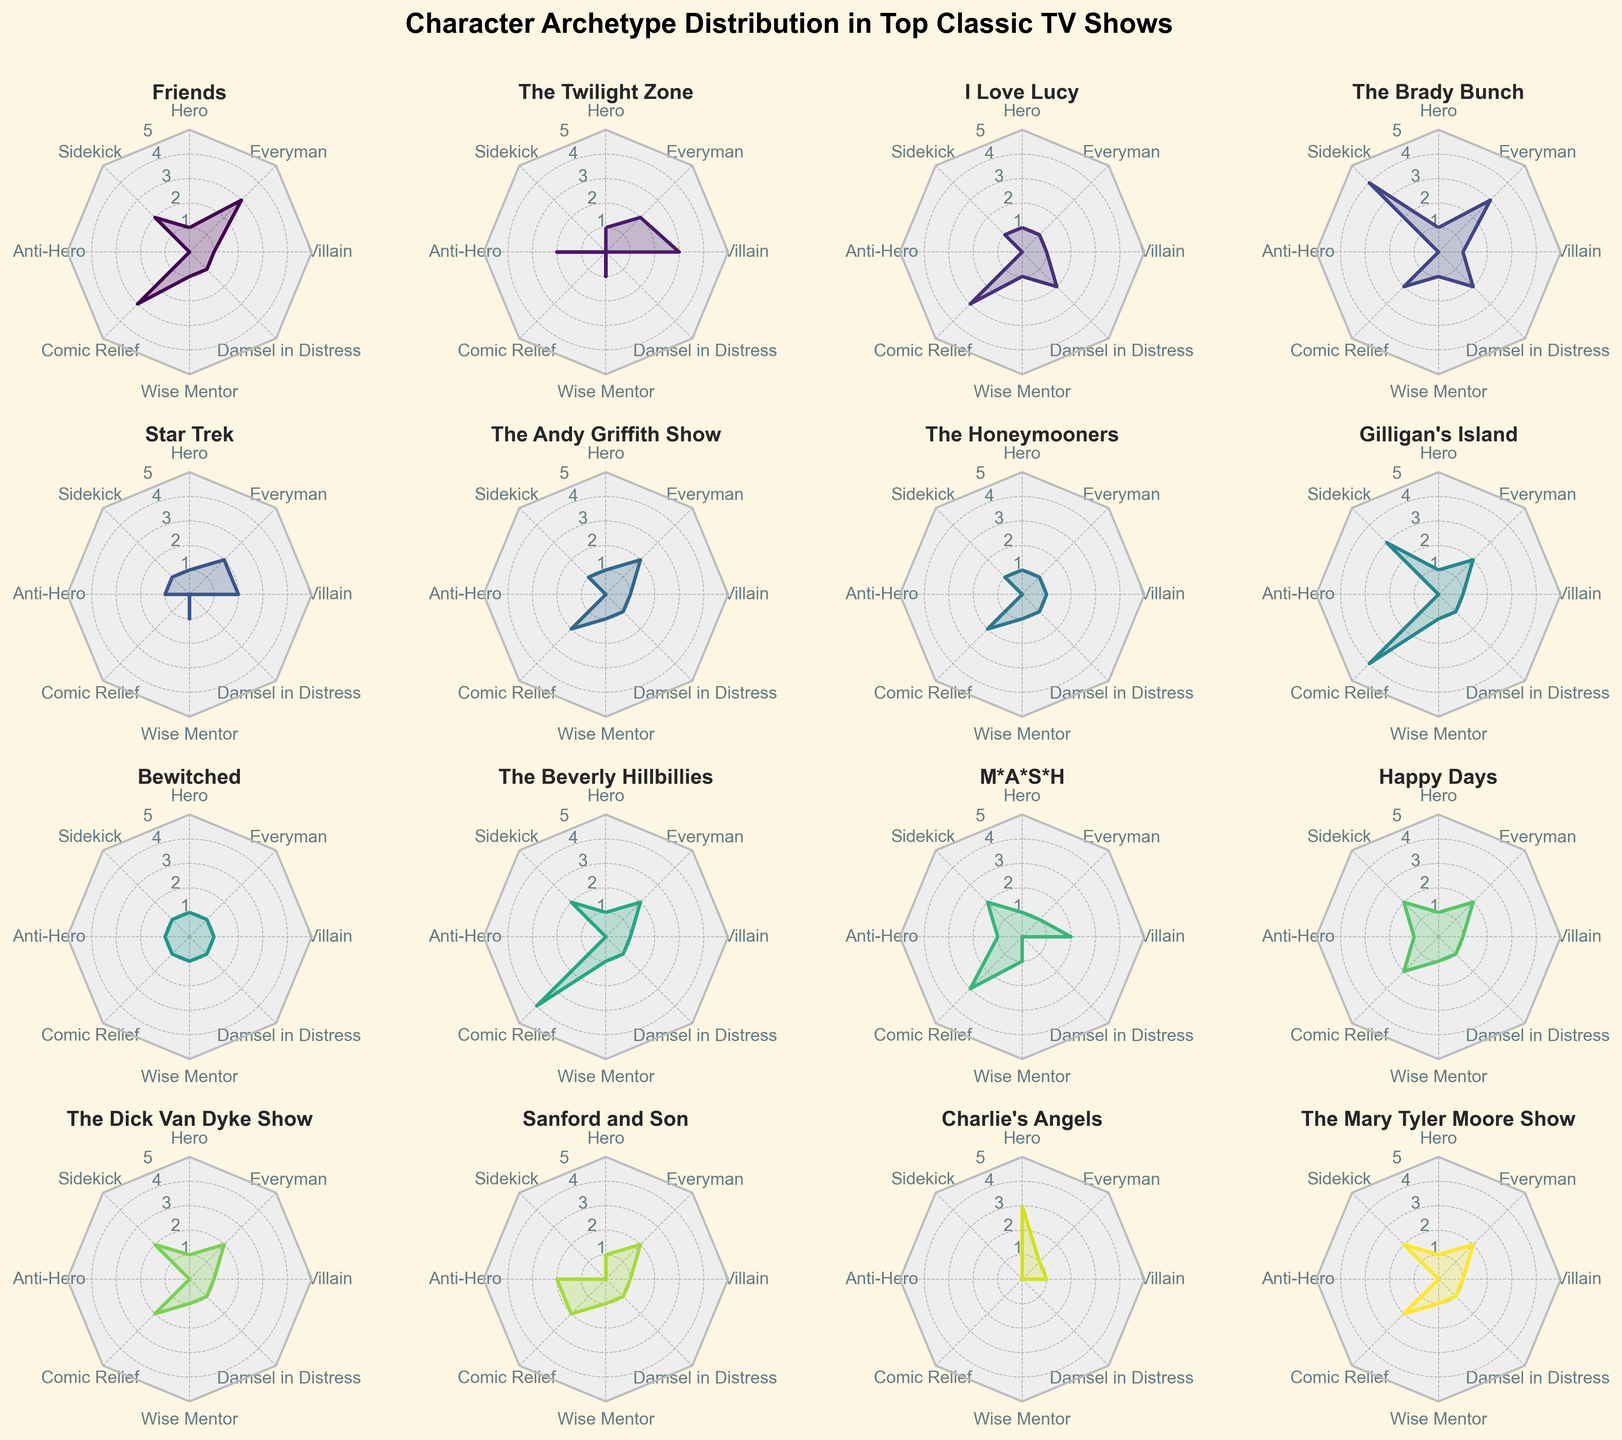How many character archetypes are shown in total on the radar charts? There are 8 different character archetypes displayed in each radar chart. You can see them labeled around each plot: Hero, Sidekick, Anti-Hero, Comic Relief, Wise Mentor, Damsel in Distress, Villain, and Everyman.
Answer: 8 Which show has the most Sidekicks? By examining the radar charts for each show, "The Brady Bunch" has the highest value for the Sidekick archetype with a count of 4.
Answer: The Brady Bunch In which show is the 'Comic Relief' archetype most prominent? The radar charts indicate that "Gilligan's Island" has the highest value for the Comic Relief archetype with a count of 4.
Answer: Gilligan's Island What is the combined total of 'Anti-Hero' characters in 'The Twilight Zone' and 'Sanford and Son'? Looking at the radar charts, "The Twilight Zone" has 2 Anti-Heroes and "Sanford and Son" also has 2 Anti-Heroes. Summing these up gives 4 in total.
Answer: 4 Which show places the least emphasis on the 'Wise Mentor' archetype? Examining the charts, several shows only have one Wise Mentor. Upon closer inspection of the charts, both "Charlie's Angels" and "The Twilight Zone" appear to place the least emphasis on the Wise Mentor archetype with a count of 0 each.
Answer: Charlie's Angels, The Twilight Zone Do any shows have an equal number of ‘Damsel in Distress’ and ‘Villain’ characters? By checking the radar charts, we find that "Friends," "The Andy Griffith Show," and "The Brady Bunch" have an equal count of 1 for both the Damsel in Distress and Villain archetypes.
Answer: Friends, The Andy Griffith Show, The Brady Bunch Which show has the highest aggregate count across all archetypes? To determine this, we need to sum up the values of all archetypes for each show. "Gilligan's Island" has the highest aggregate count: 1 (Hero) + 3 (Sidekick) + 0 (Anti-Hero) + 4 (Comic Relief) + 1 (Wise Mentor) + 1 (Damsel in Distress) + 1 (Villain) + 2 (Everyman) = 13.
Answer: Gilligan's Island How many shows feature at least one 'Everyman' character? Examining the radar charts shows that the majority of the listed shows feature at least one Everyman character. By counting them, we find that 13 shows have a count of 1 or more for Everyman.
Answer: 13 Which chart features the most balanced distribution of character archetypes? Examining each radar chart for balance (where all categories have similar values), "Bewitched" stands out as having a balanced distribution with every archetype having a count of 1.
Answer: Bewitched 